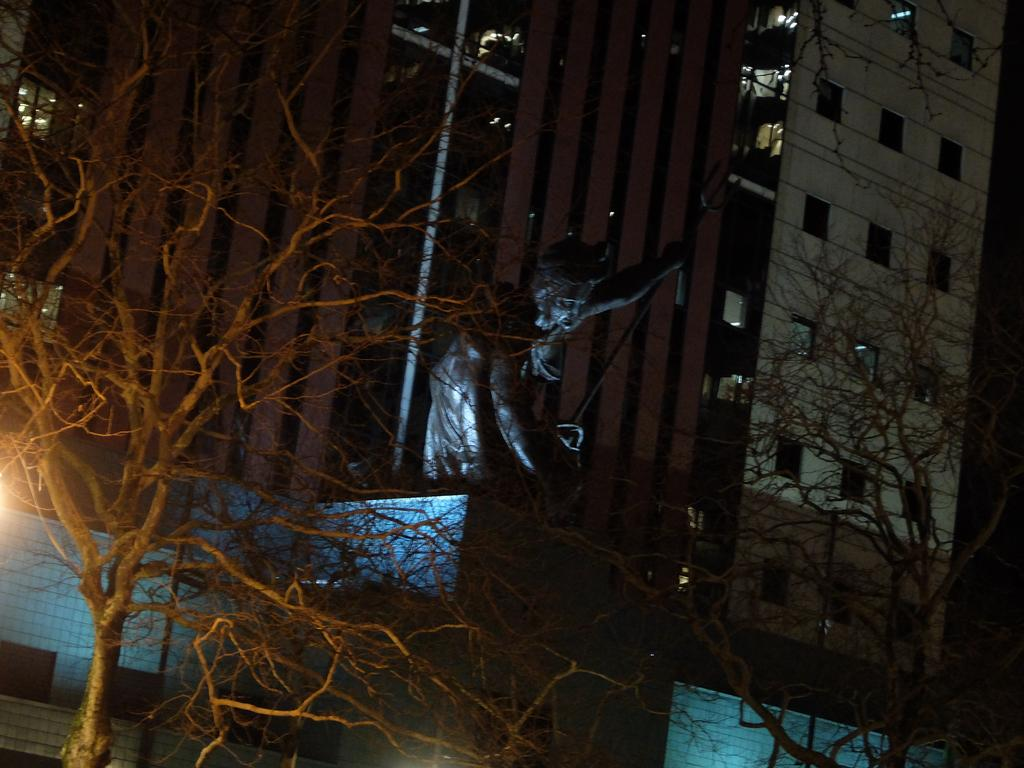What type of natural elements can be seen in the image? There are trees in the image. What type of artwork is present in the image? There is a sculpture of a person in the image. What type of structure can be seen in the background of the image? There is a building in the background of the image. How many tomatoes are growing on the trees in the image? There are no tomatoes present in the image, as it only features trees. What type of society is depicted in the sculpture in the image? There is no society depicted in the sculpture; it is a sculpture of a person. 